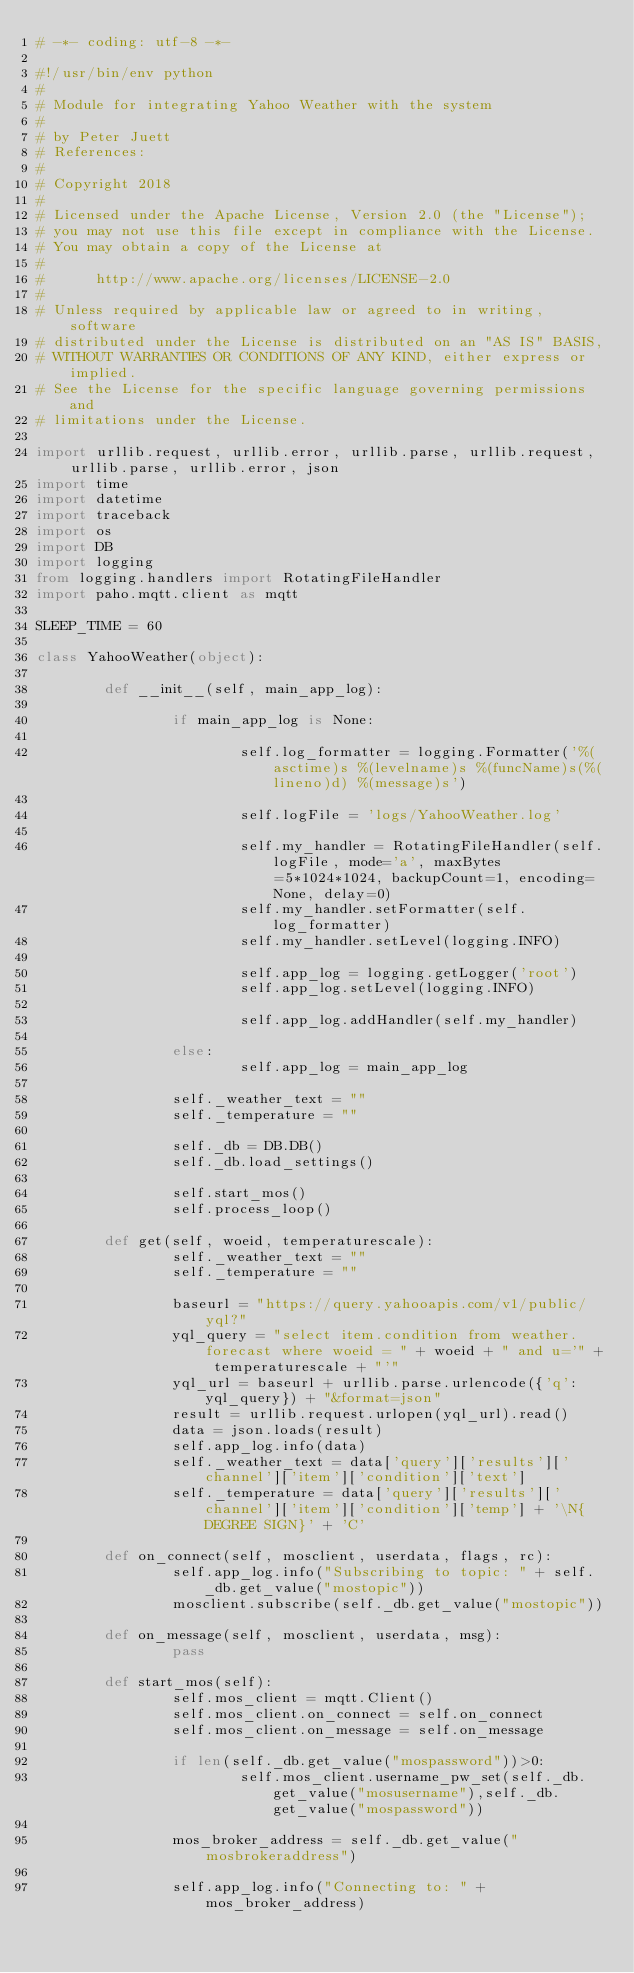Convert code to text. <code><loc_0><loc_0><loc_500><loc_500><_Python_># -*- coding: utf-8 -*-

#!/usr/bin/env python
#
# Module for integrating Yahoo Weather with the system
#
# by Peter Juett
# References:
#
# Copyright 2018
#
# Licensed under the Apache License, Version 2.0 (the "License");
# you may not use this file except in compliance with the License.
# You may obtain a copy of the License at
#
#      http://www.apache.org/licenses/LICENSE-2.0
#
# Unless required by applicable law or agreed to in writing, software
# distributed under the License is distributed on an "AS IS" BASIS,
# WITHOUT WARRANTIES OR CONDITIONS OF ANY KIND, either express or implied.
# See the License for the specific language governing permissions and
# limitations under the License.

import urllib.request, urllib.error, urllib.parse, urllib.request, urllib.parse, urllib.error, json
import time
import datetime
import traceback
import os
import DB
import logging
from logging.handlers import RotatingFileHandler
import paho.mqtt.client as mqtt

SLEEP_TIME = 60

class YahooWeather(object):

        def __init__(self, main_app_log):

                if main_app_log is None:

                        self.log_formatter = logging.Formatter('%(asctime)s %(levelname)s %(funcName)s(%(lineno)d) %(message)s')

                        self.logFile = 'logs/YahooWeather.log'

                        self.my_handler = RotatingFileHandler(self.logFile, mode='a', maxBytes=5*1024*1024, backupCount=1, encoding=None, delay=0)
                        self.my_handler.setFormatter(self.log_formatter)
                        self.my_handler.setLevel(logging.INFO)

                        self.app_log = logging.getLogger('root')
                        self.app_log.setLevel(logging.INFO)

                        self.app_log.addHandler(self.my_handler)

                else:
                        self.app_log = main_app_log

                self._weather_text = ""
                self._temperature = ""

                self._db = DB.DB()
                self._db.load_settings()

                self.start_mos()
                self.process_loop()

        def get(self, woeid, temperaturescale):
                self._weather_text = ""
                self._temperature = ""
        
                baseurl = "https://query.yahooapis.com/v1/public/yql?"
                yql_query = "select item.condition from weather.forecast where woeid = " + woeid + " and u='" + temperaturescale + "'"
                yql_url = baseurl + urllib.parse.urlencode({'q':yql_query}) + "&format=json"
                result = urllib.request.urlopen(yql_url).read()
                data = json.loads(result)
                self.app_log.info(data)
                self._weather_text = data['query']['results']['channel']['item']['condition']['text']
                self._temperature = data['query']['results']['channel']['item']['condition']['temp'] + '\N{DEGREE SIGN}' + 'C'

        def on_connect(self, mosclient, userdata, flags, rc):
                self.app_log.info("Subscribing to topic: " + self._db.get_value("mostopic"))
                mosclient.subscribe(self._db.get_value("mostopic"))

        def on_message(self, mosclient, userdata, msg):
                pass

        def start_mos(self):
                self.mos_client = mqtt.Client()
                self.mos_client.on_connect = self.on_connect
                self.mos_client.on_message = self.on_message

                if len(self._db.get_value("mospassword"))>0:
                        self.mos_client.username_pw_set(self._db.get_value("mosusername"),self._db.get_value("mospassword"))

                mos_broker_address = self._db.get_value("mosbrokeraddress") 

                self.app_log.info("Connecting to: " + mos_broker_address)
</code> 